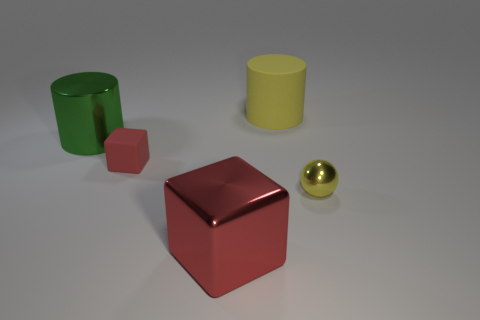There is a yellow thing to the right of the yellow rubber thing; is it the same size as the cylinder that is on the right side of the large cube?
Your answer should be compact. No. How many large objects have the same shape as the tiny red object?
Provide a short and direct response. 1. What shape is the green object that is the same material as the tiny yellow sphere?
Offer a terse response. Cylinder. There is a big thing in front of the big thing that is left of the red cube to the right of the tiny rubber cube; what is it made of?
Provide a short and direct response. Metal. There is a matte block; does it have the same size as the shiny ball in front of the tiny rubber object?
Your answer should be compact. Yes. There is a small thing that is the same shape as the large red object; what is its material?
Give a very brief answer. Rubber. There is a thing behind the large cylinder that is to the left of the yellow object behind the yellow ball; how big is it?
Your answer should be very brief. Large. Does the green cylinder have the same size as the red shiny cube?
Ensure brevity in your answer.  Yes. What material is the tiny yellow object in front of the big shiny object behind the sphere made of?
Give a very brief answer. Metal. There is a large thing that is in front of the small yellow metallic sphere; does it have the same shape as the rubber object that is behind the small red matte object?
Provide a short and direct response. No. 